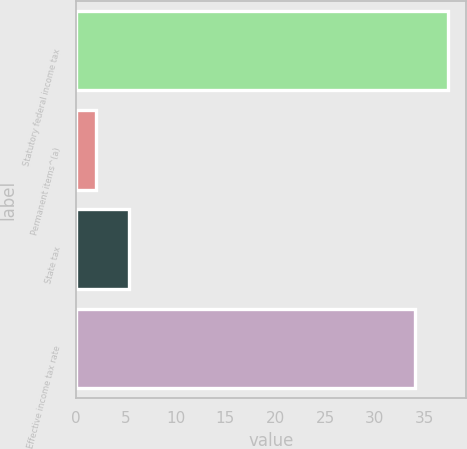<chart> <loc_0><loc_0><loc_500><loc_500><bar_chart><fcel>Statutory federal income tax<fcel>Permanent items^(a)<fcel>State tax<fcel>Effective income tax rate<nl><fcel>37.3<fcel>2<fcel>5.3<fcel>34<nl></chart> 